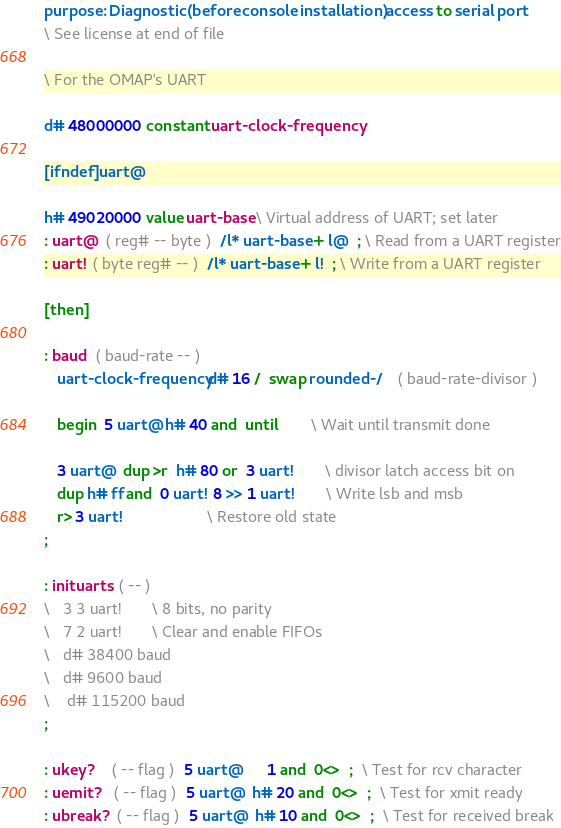Convert code to text. <code><loc_0><loc_0><loc_500><loc_500><_Forth_>purpose: Diagnostic (before console installation) access to serial port
\ See license at end of file

\ For the OMAP's UART

d# 48000000 constant uart-clock-frequency

[ifndef] uart@

h# 49020000 value uart-base \ Virtual address of UART; set later
: uart@  ( reg# -- byte )  /l* uart-base + l@  ; \ Read from a UART register
: uart!  ( byte reg# -- )  /l* uart-base + l!  ; \ Write from a UART register

[then]

: baud  ( baud-rate -- )
   uart-clock-frequency d# 16 /  swap rounded-/    ( baud-rate-divisor )

   begin  5 uart@ h# 40 and  until		\ Wait until transmit done

   3 uart@  dup >r  h# 80 or  3 uart!		\ divisor latch access bit on
   dup h# ff and  0 uart!  8 >> 1 uart!		\ Write lsb and msb
   r> 3 uart!					\ Restore old state
;

: inituarts  ( -- )
\   3 3 uart!  		\ 8 bits, no parity
\   7 2 uart!		\ Clear and enable FIFOs
\   d# 38400 baud
\   d# 9600 baud
\    d# 115200 baud
;

: ukey?    ( -- flag )  5 uart@      1 and  0<>  ;  \ Test for rcv character
: uemit?   ( -- flag )  5 uart@  h# 20 and  0<>  ;  \ Test for xmit ready
: ubreak?  ( -- flag )  5 uart@  h# 10 and  0<>  ;  \ Test for received break</code> 